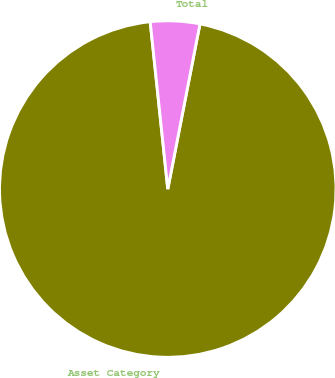Convert chart to OTSL. <chart><loc_0><loc_0><loc_500><loc_500><pie_chart><fcel>Asset Category<fcel>Total<nl><fcel>95.27%<fcel>4.73%<nl></chart> 